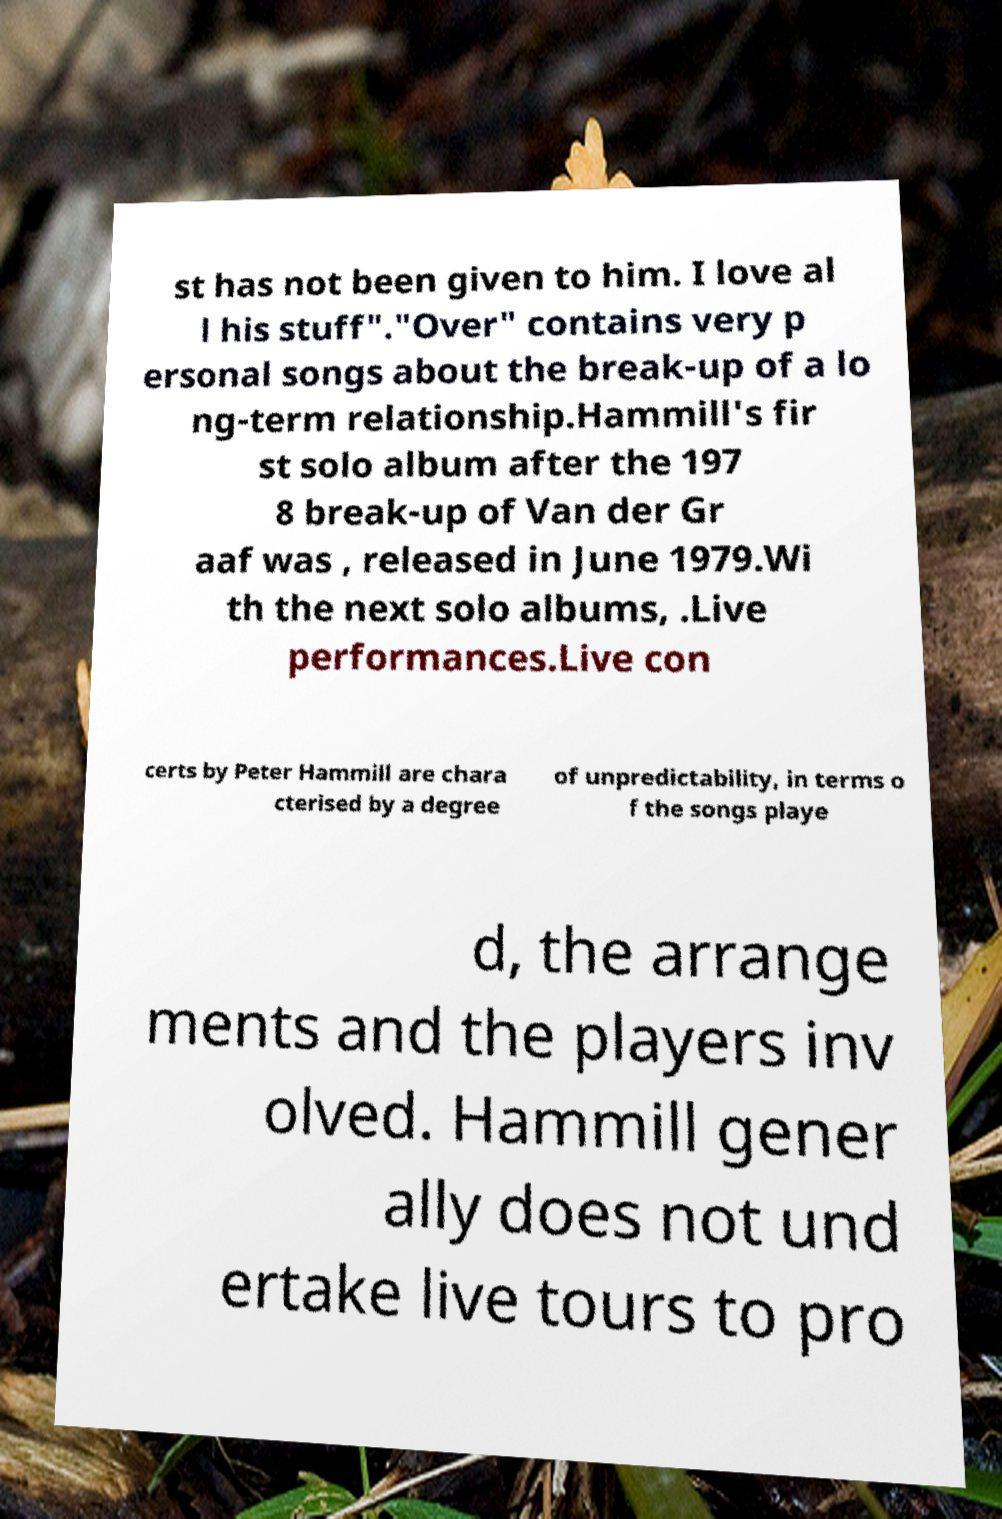Can you accurately transcribe the text from the provided image for me? st has not been given to him. I love al l his stuff"."Over" contains very p ersonal songs about the break-up of a lo ng-term relationship.Hammill's fir st solo album after the 197 8 break-up of Van der Gr aaf was , released in June 1979.Wi th the next solo albums, .Live performances.Live con certs by Peter Hammill are chara cterised by a degree of unpredictability, in terms o f the songs playe d, the arrange ments and the players inv olved. Hammill gener ally does not und ertake live tours to pro 